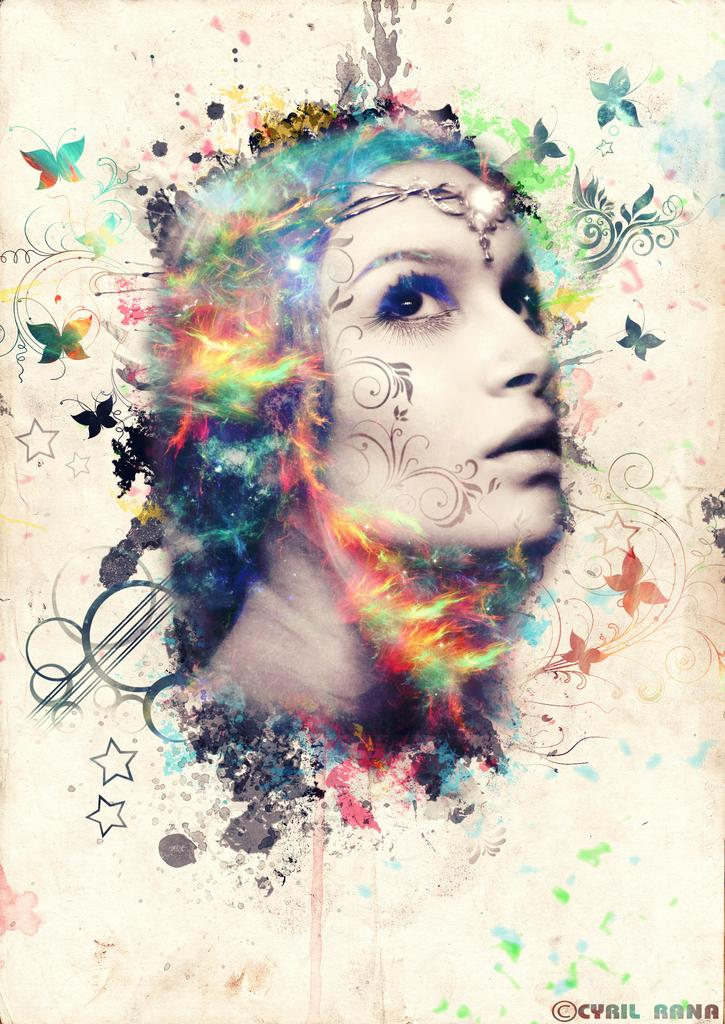What can be observed about the nature of the image? The image is edited. What is the main subject in the center of the image? There is a depiction of a woman in the center of the image. How many balls are being washed by the woman in the image? There are no balls or any indication of washing in the image; it features a depiction of a woman. What type of ice can be seen melting around the woman in the image? There is no ice present in the image; it only features a depiction of a woman. 